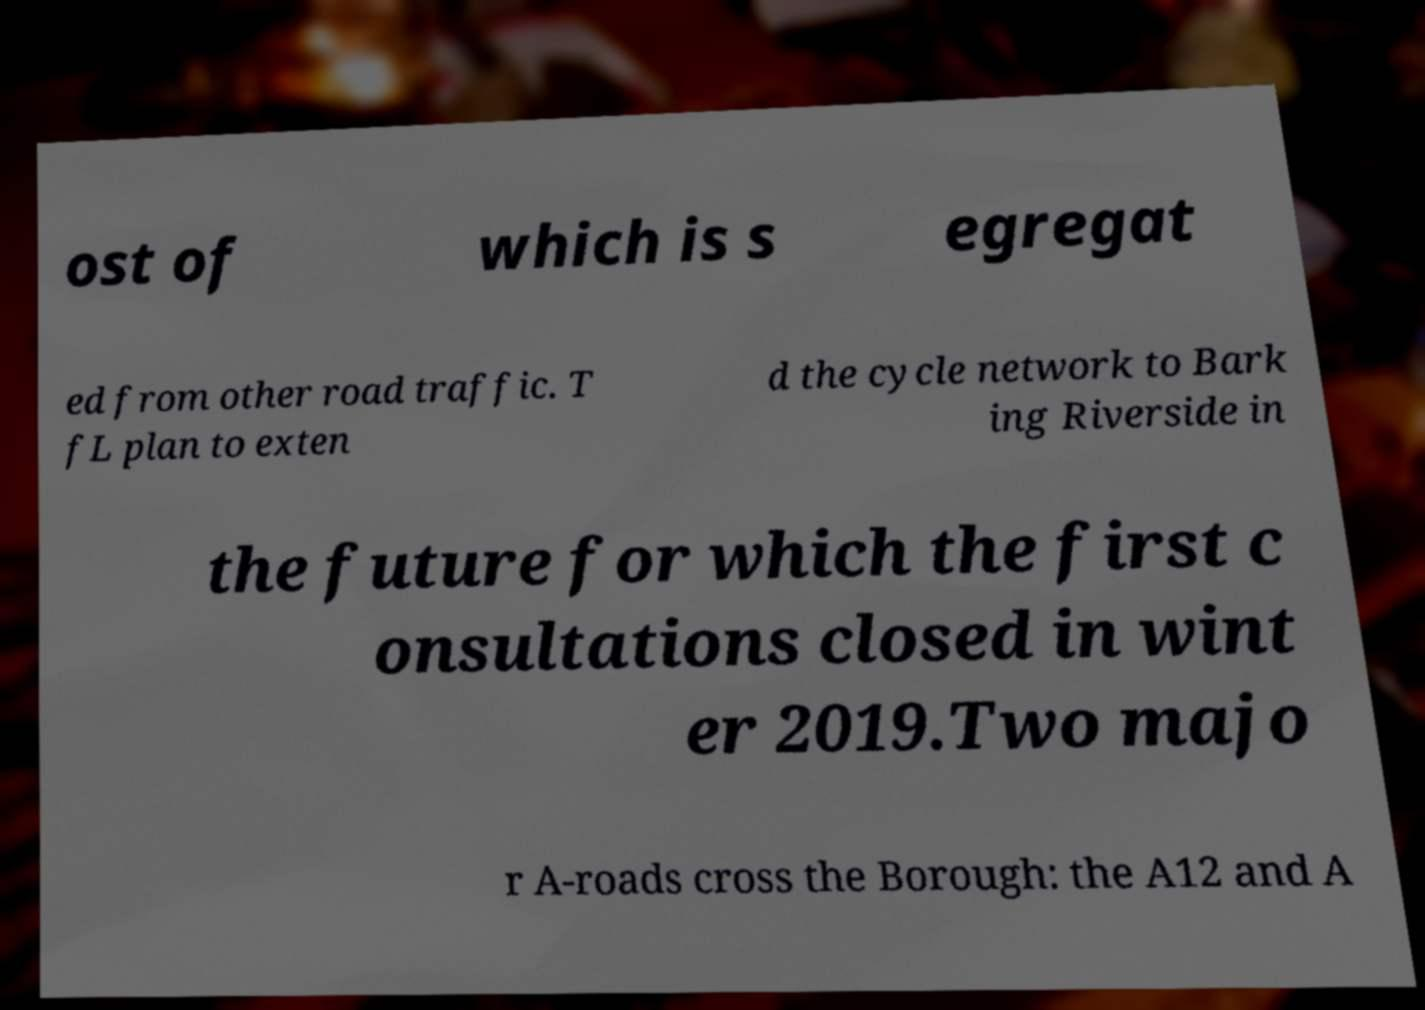Can you read and provide the text displayed in the image?This photo seems to have some interesting text. Can you extract and type it out for me? ost of which is s egregat ed from other road traffic. T fL plan to exten d the cycle network to Bark ing Riverside in the future for which the first c onsultations closed in wint er 2019.Two majo r A-roads cross the Borough: the A12 and A 